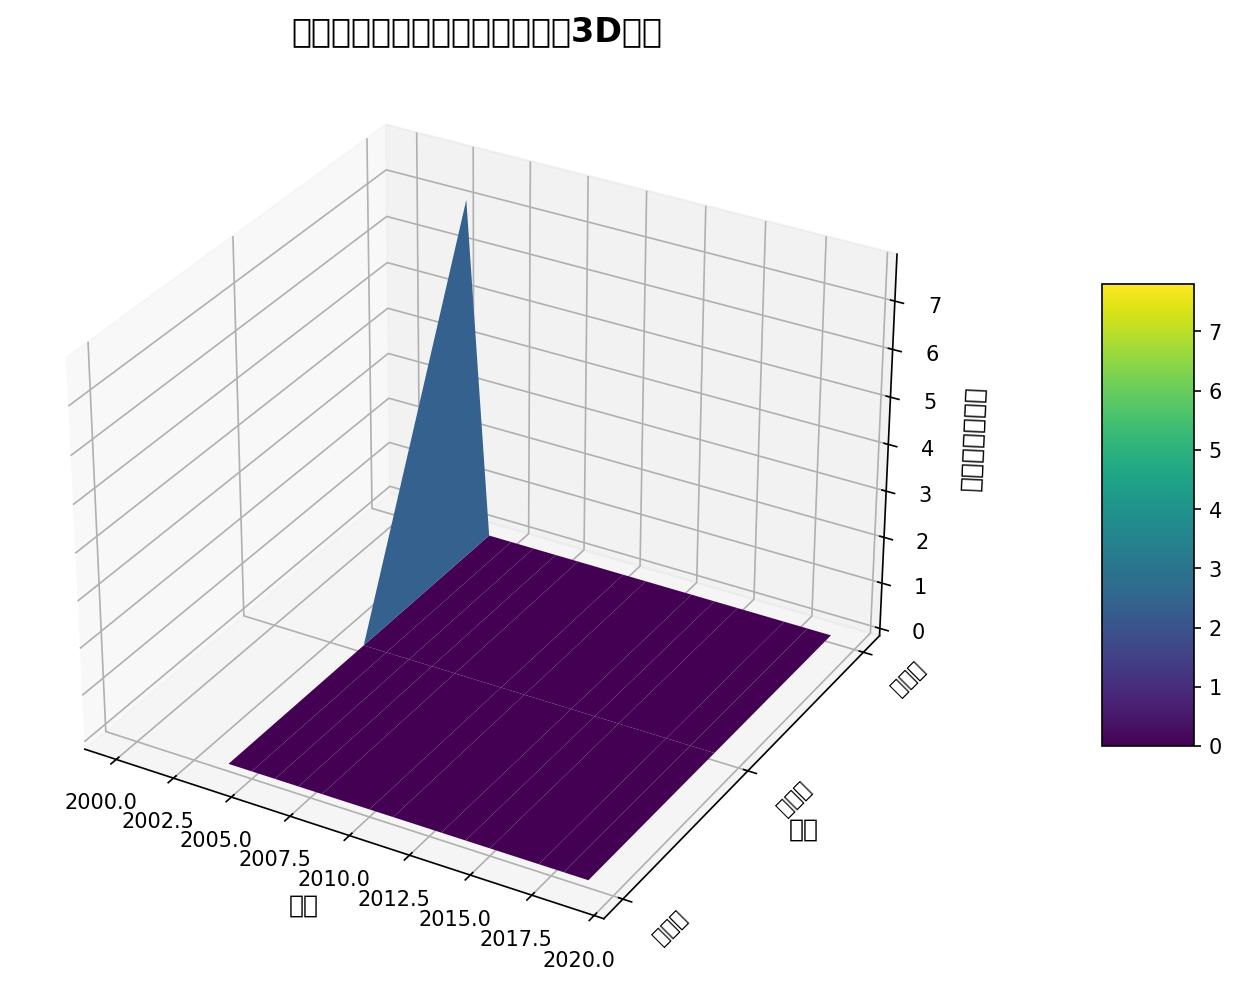什么赛事中球员表现平均分的最高值是多少？ 查看图表中'球员表现平均分'轴上的最高值，可以看到其最大值对应某个赛事的表面最高点。
Answer: 8.0 哪一年韩国国家队在亚洲杯中表现最好？ 查看亚洲杯的数据，找到'球员表现平均分'最高的年份。这需要查看图表中的每一年并比较其'球员表现平均分'。2015年的球员表现平均分最高。
Answer: 2015 韩国国家队在东亚杯和世界杯中的球员表现平均分相差最大的一年是？ 比较东亚杯和世界杯在各年份的'球员表现平均分'，识别差距最大的年份。例如，通过检查2002年和2005年相对应的数据，我们看到2002年世界杯的球员表现显著高于同年的东亚杯。
Answer: 2002 2004年和2015年相比，东亚杯和亚洲杯的球员表现哪个更高？ 比较2004年和2015年的东亚杯和亚洲杯的'球员表现平均分'，分别找到每一年的两项赛事的数值并进行比较。
Answer: 2015年的亚洲杯 哪两届世界杯的球员表现平均分最相近？ 查看每届世界杯的'球员表现平均分'并找到两个最接近的值。例如，通过检查2006年和2010年世界杯的数值，发现其表现接近。
Answer: 2006, 2010 球员表现平均分最低的一年是哪一年？ 查看图表中'球员表现平均分'轴的最低点，并找到对应的年份。例如，由于2005年东亚杯数据最低，因此回答为2005年。
Answer: 2005 在2010年，韩国国家队三个赛事的球员表现平均分分别是多少？ 从图表中查找2010年的数据，分别找到每个赛事（世界杯、亚洲杯、东亚杯）的'球员表现平均分'。通过检查看到2010年数据，分别为世界杯7.0，亚洲杯无数据，东亚杯7.4。
Answer: 7.0 (世界杯), 7.4 (东亚杯) 哪一年世界杯和亚洲杯的球员表现平均分差距最大？ 比较各年份世界杯和亚洲杯各自的'球员表现平均分'，找到差距最大的年份。例如，看到2010年世界杯和亚洲杯之间的差距最大。
Answer: 2010 